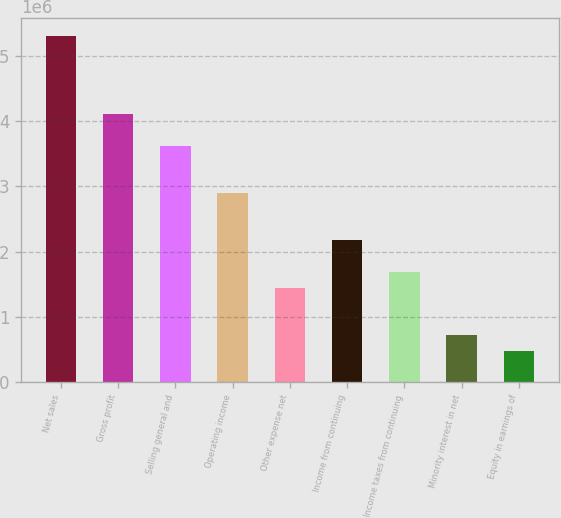Convert chart. <chart><loc_0><loc_0><loc_500><loc_500><bar_chart><fcel>Net sales<fcel>Gross profit<fcel>Selling general and<fcel>Operating income<fcel>Other expense net<fcel>Income from continuing<fcel>Income taxes from continuing<fcel>Minority interest in net<fcel>Equity in earnings of<nl><fcel>5.30871e+06<fcel>4.10218e+06<fcel>3.61957e+06<fcel>2.89566e+06<fcel>1.44783e+06<fcel>2.17175e+06<fcel>1.68914e+06<fcel>723916<fcel>482611<nl></chart> 